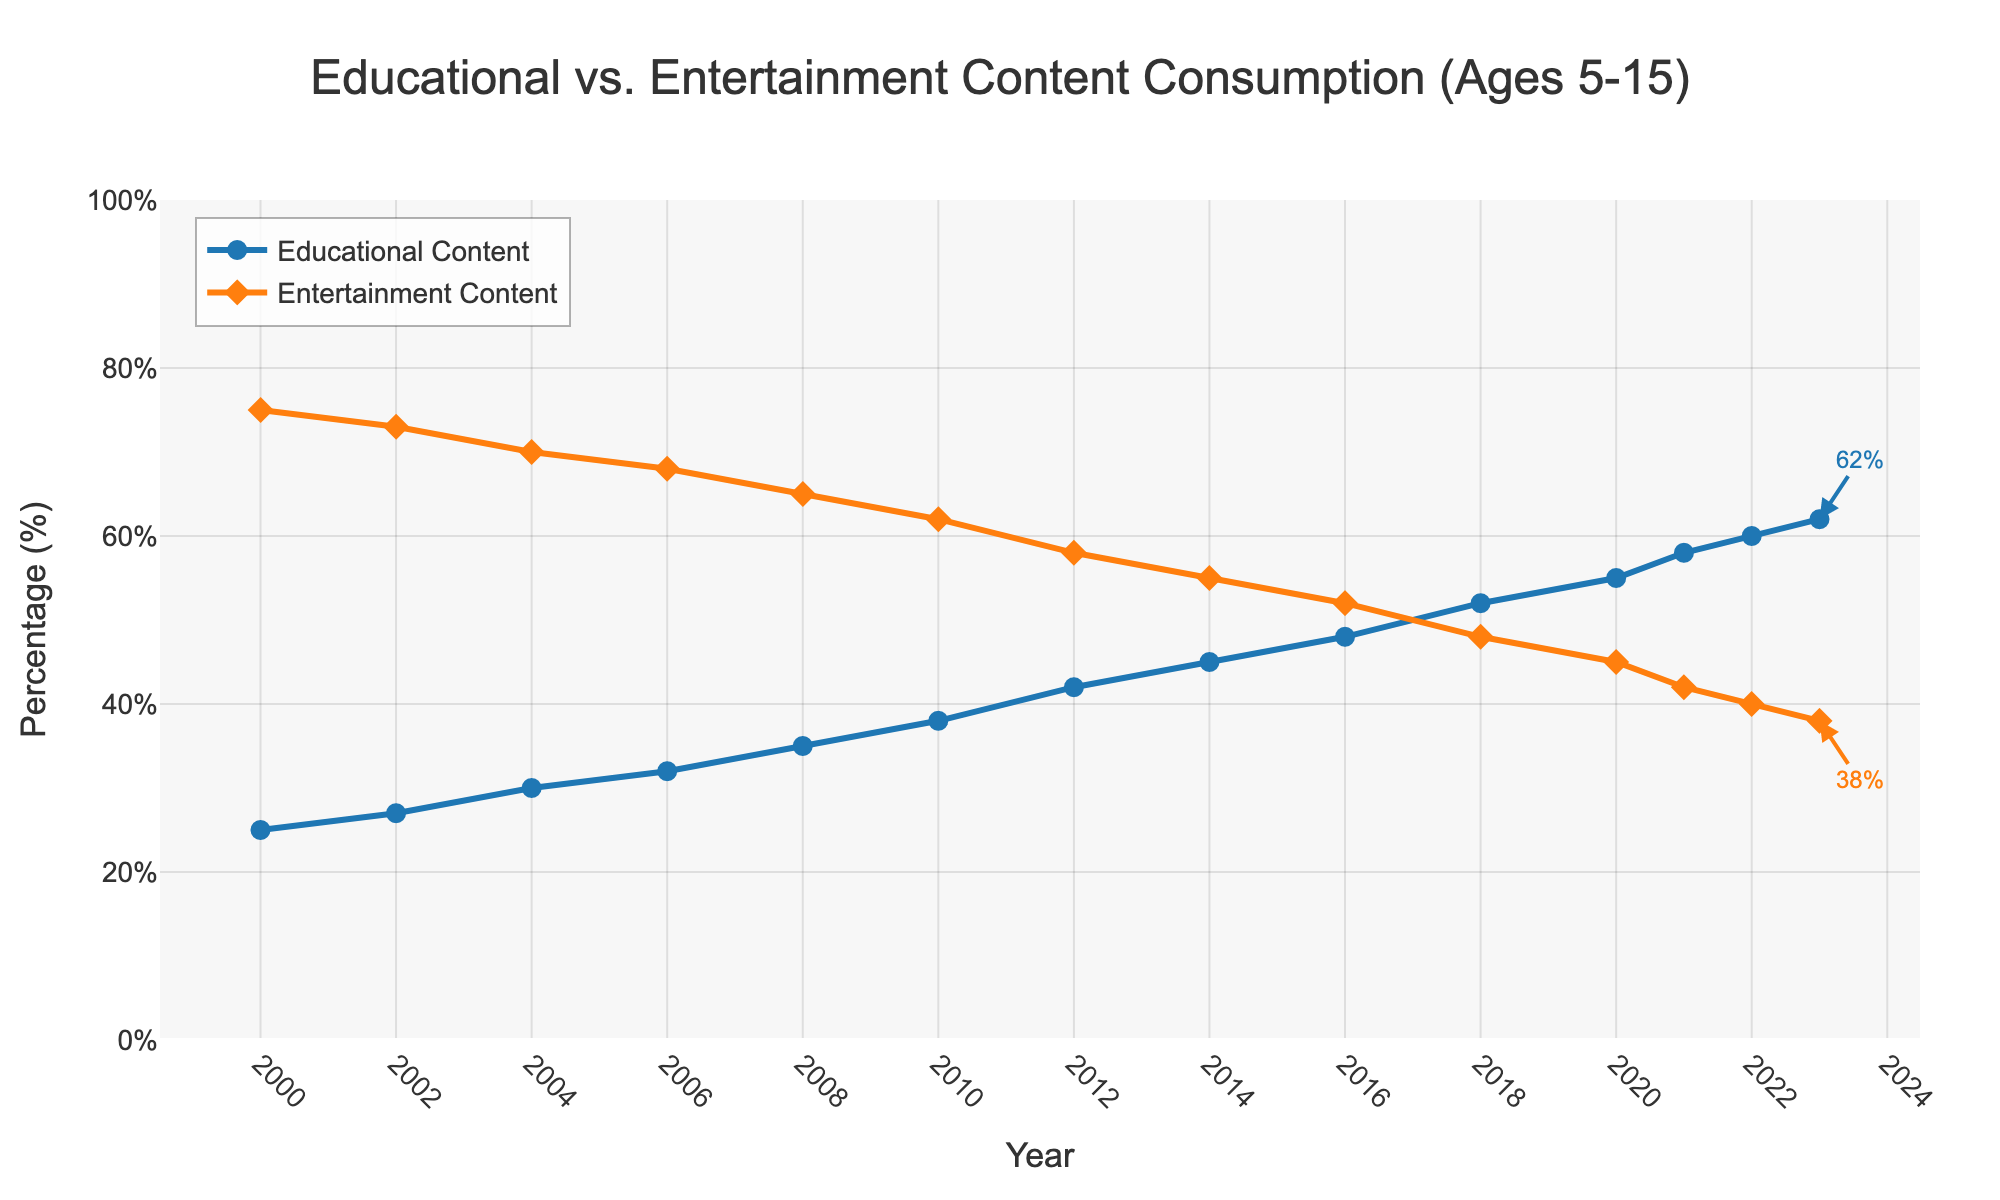What is the percentage of educational content consumption in 2023? To find the answer, look at the end of the "Educational Content" line (blue) on the chart in 2023. The annotation reads 62%.
Answer: 62% How much did the percentage of entertainment content consumption decrease from 2000 to 2023? First, find the percentage for 2000 and 2023 in the "Entertainment Content" line (orange). In 2000, it is 75%, and in 2023, it is 38%. The change is 75% - 38% = 37%.
Answer: 37% By how much percent did the educational content consumption increase between 2010 and 2020? Find the percentages in 2010 and 2020 for "Educational Content". In 2010, it is 38%, and in 2020, it is 55%. The increase is 55% - 38% = 17%.
Answer: 17% Which year saw an equal percentage of educational and entertainment content consumption? Locate the point where the "Educational Content" and "Entertainment Content" lines intersect. This happens around 2018. Verify with 52% for both lines.
Answer: 2018 In which year did educational content consumption first exceed 40%? Look for the first year in the "Educational Content" line where the percentage is above 40%. This happens in 2012.
Answer: 2012 What is the difference between the maximum and minimum percentage values for educational content throughout the years? The minimum is in 2000 with 25%, and the maximum is in 2023 with 62%. The difference is 62% - 25% = 37%.
Answer: 37% How much more was the percentage of entertainment content consumed in 2008 compared to educational content in the same year? In 2008, the "Entertainment Content" is 65%, and "Educational Content" is 35%. The difference is 65% - 35% = 30%.
Answer: 30% In which years did the consumption of educational content increase by a significant 5% or more compared to the previous period? Look for periods where the slope of the "Educational Content" line shows an increase of 5% or more. This happens between 2008-2010, 2012-2014, and 2014-2016.
Answer: 2008-2010, 2012-2014, 2014-2016 